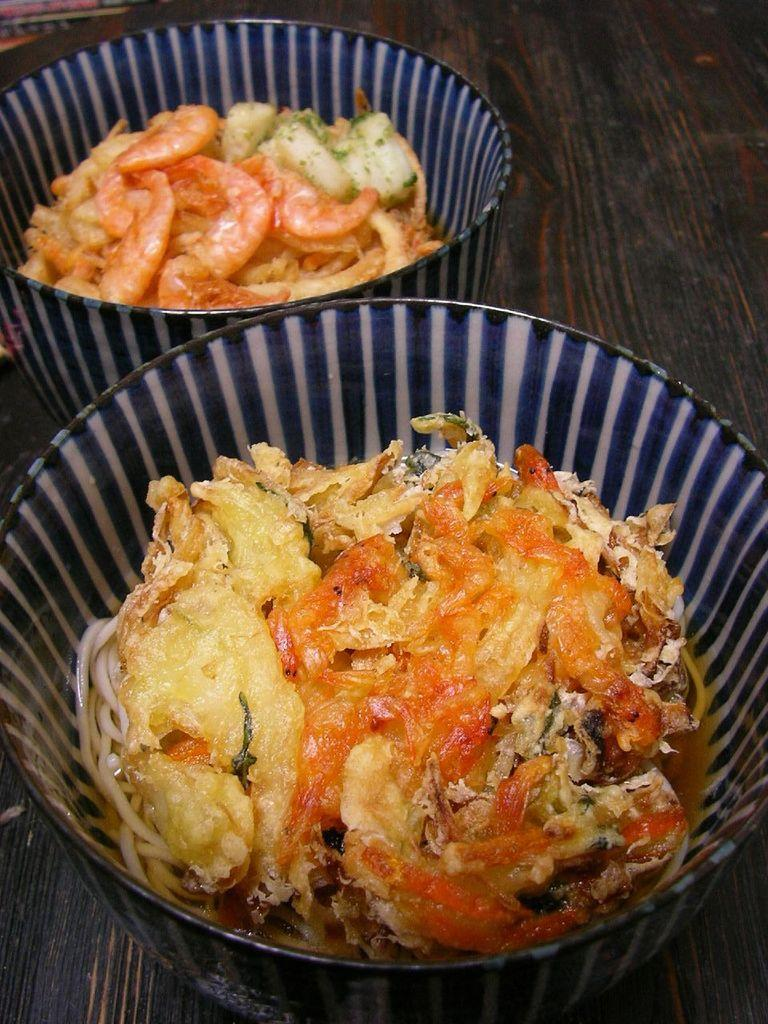What is located in the center of the image? There is a table in the center of the image. What is placed on the table? There are bowls on the table. What is inside the bowls? There are food items in the bowls. What type of insurance policy is being discussed at the table in the image? There is no indication of any insurance policy being discussed in the image; it features a table with bowls containing food items. 